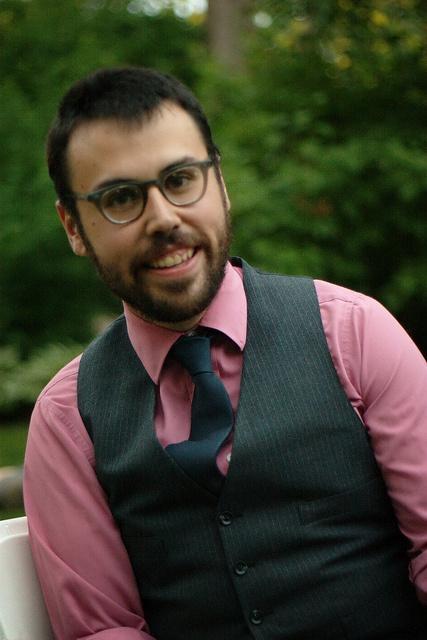Describe the objects in this image and their specific colors. I can see people in darkgreen, black, brown, maroon, and lightpink tones, tie in darkgreen, black, darkblue, blue, and purple tones, and bench in darkgreen, darkgray, lightgray, and gray tones in this image. 